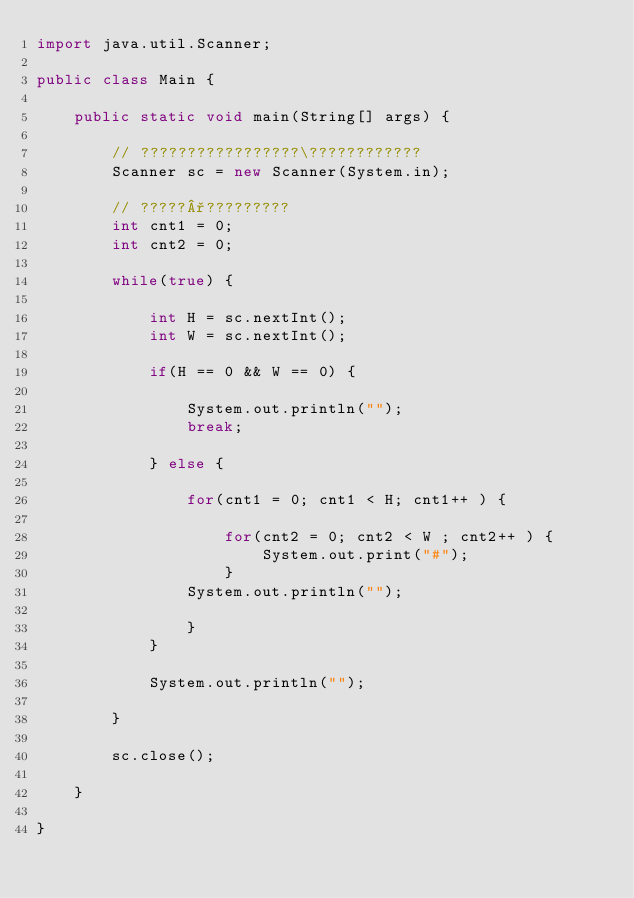<code> <loc_0><loc_0><loc_500><loc_500><_Java_>import java.util.Scanner;

public class Main {

	public static void main(String[] args) {

		// ?????????????????\????????????
		Scanner sc = new Scanner(System.in);

		// ?????°?????????
		int cnt1 = 0;
		int cnt2 = 0;

		while(true) {

			int H = sc.nextInt();
			int W = sc.nextInt();

			if(H == 0 && W == 0) {

				System.out.println("");
				break;

			} else {

				for(cnt1 = 0; cnt1 < H; cnt1++ ) {

					for(cnt2 = 0; cnt2 < W ; cnt2++ ) {
						System.out.print("#");
					}
				System.out.println("");

				}
			}
			
			System.out.println("");

		}

		sc.close();

	}

}</code> 